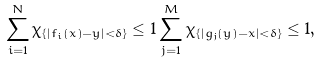<formula> <loc_0><loc_0><loc_500><loc_500>\sum _ { i = 1 } ^ { N } \chi _ { \{ | f _ { i } ( x ) - y | < \delta \} } \leq 1 \sum _ { j = 1 } ^ { M } \chi _ { \{ | g _ { j } ( y ) - x | < \delta \} } \leq 1 ,</formula> 